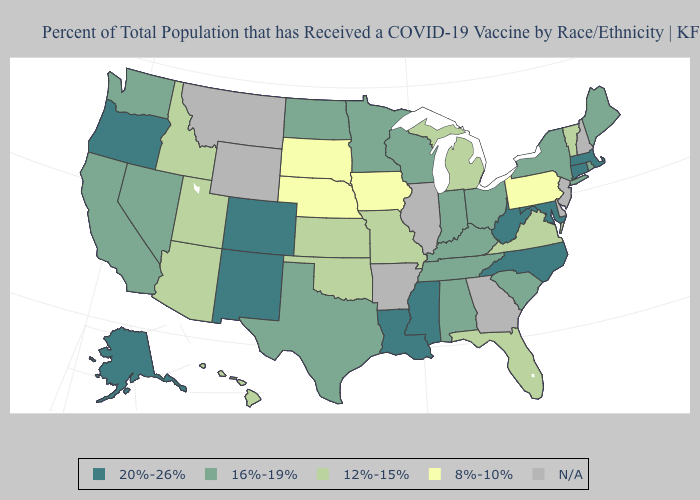What is the value of Nebraska?
Give a very brief answer. 8%-10%. Does the map have missing data?
Keep it brief. Yes. What is the value of Georgia?
Be succinct. N/A. What is the lowest value in the USA?
Give a very brief answer. 8%-10%. What is the highest value in states that border Kentucky?
Concise answer only. 20%-26%. Among the states that border Texas , does Oklahoma have the highest value?
Answer briefly. No. Does Nebraska have the lowest value in the MidWest?
Quick response, please. Yes. What is the value of Tennessee?
Give a very brief answer. 16%-19%. How many symbols are there in the legend?
Give a very brief answer. 5. What is the highest value in the USA?
Quick response, please. 20%-26%. Which states have the lowest value in the South?
Be succinct. Florida, Oklahoma, Virginia. What is the value of Idaho?
Quick response, please. 12%-15%. Name the states that have a value in the range N/A?
Answer briefly. Arkansas, Delaware, Georgia, Illinois, Montana, New Hampshire, New Jersey, Wyoming. How many symbols are there in the legend?
Short answer required. 5. Name the states that have a value in the range 8%-10%?
Answer briefly. Iowa, Nebraska, Pennsylvania, South Dakota. 